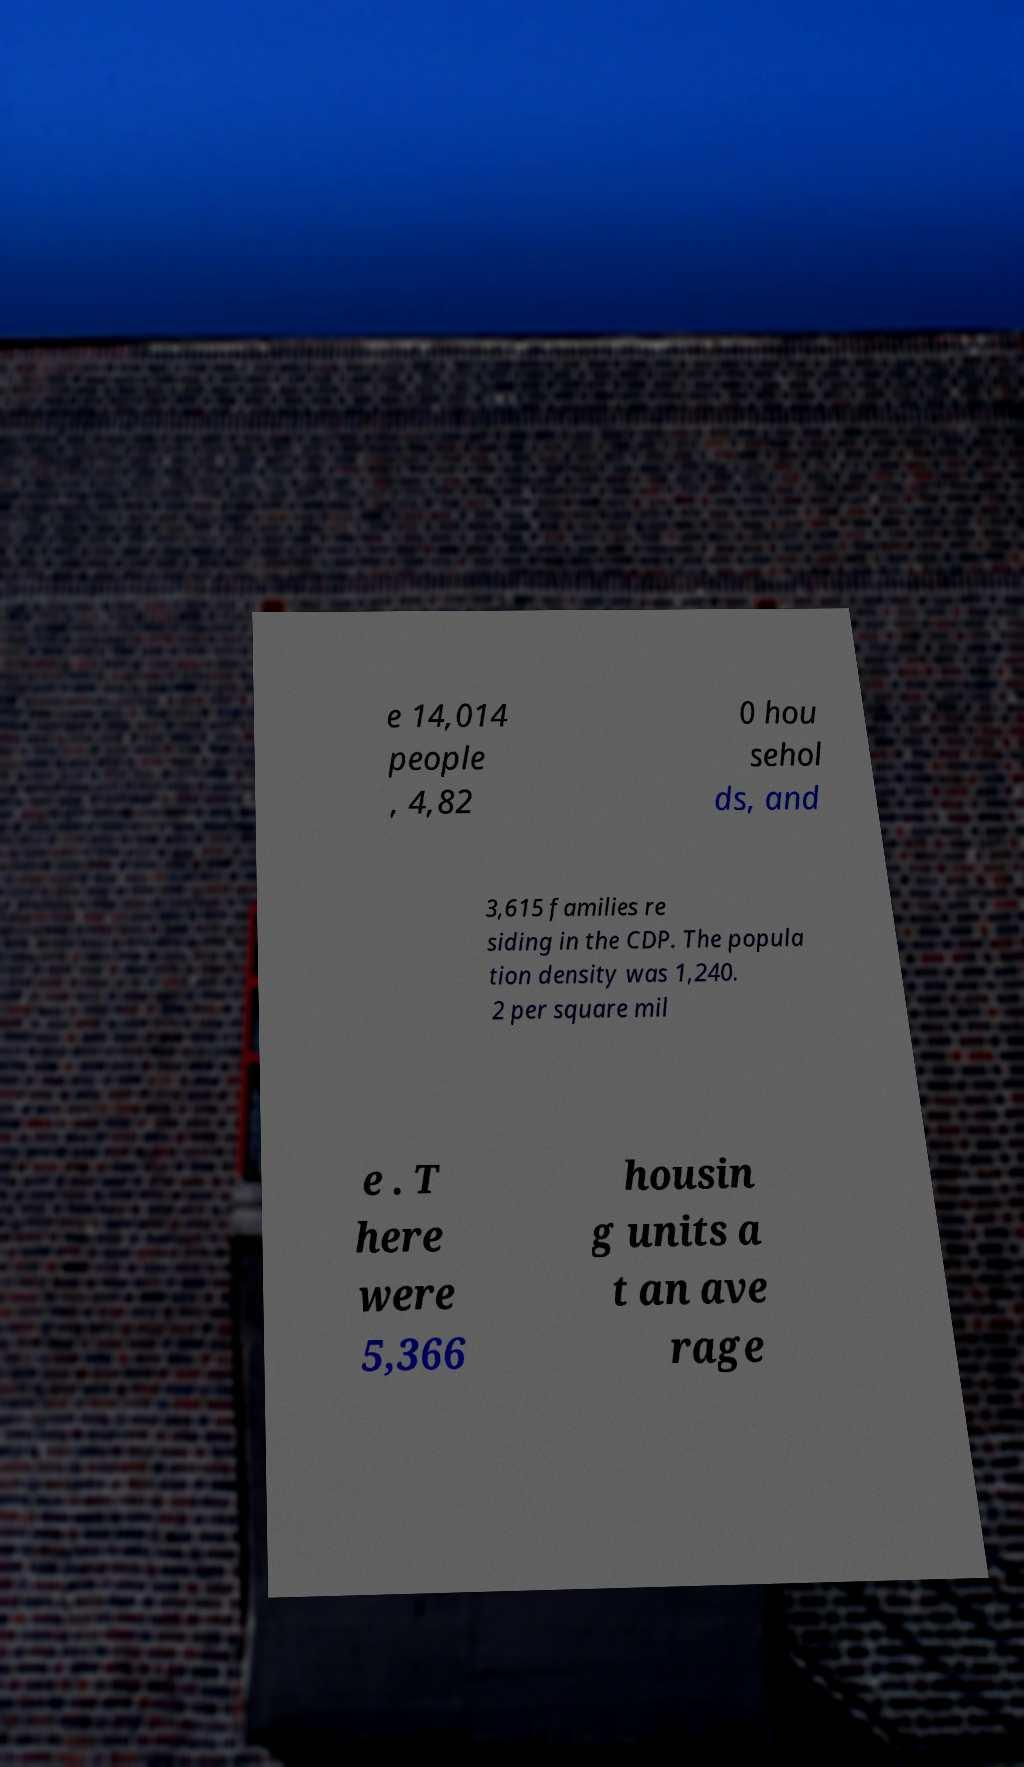Please identify and transcribe the text found in this image. e 14,014 people , 4,82 0 hou sehol ds, and 3,615 families re siding in the CDP. The popula tion density was 1,240. 2 per square mil e . T here were 5,366 housin g units a t an ave rage 